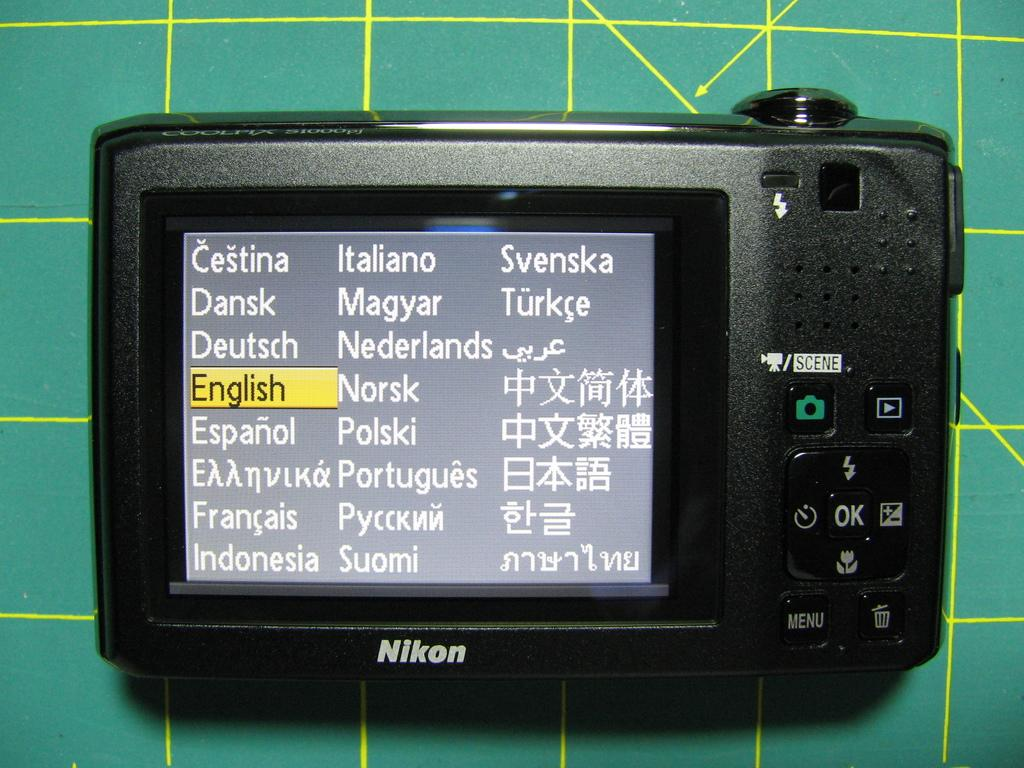What object is the main focus of the image? There is a camera in the image. What is the color of the camera? The camera is black in color. What feature does the camera have on the front? The camera has a screen in the front. Where is the camera placed in the image? The camera is placed on a desk. What is the color of the desk? The desk is green in color. Can you see any laborers working in the image? There are no laborers present in the image; it features a camera on a desk. What type of berry is being used as a prop in the image? There are no berries present in the image. 